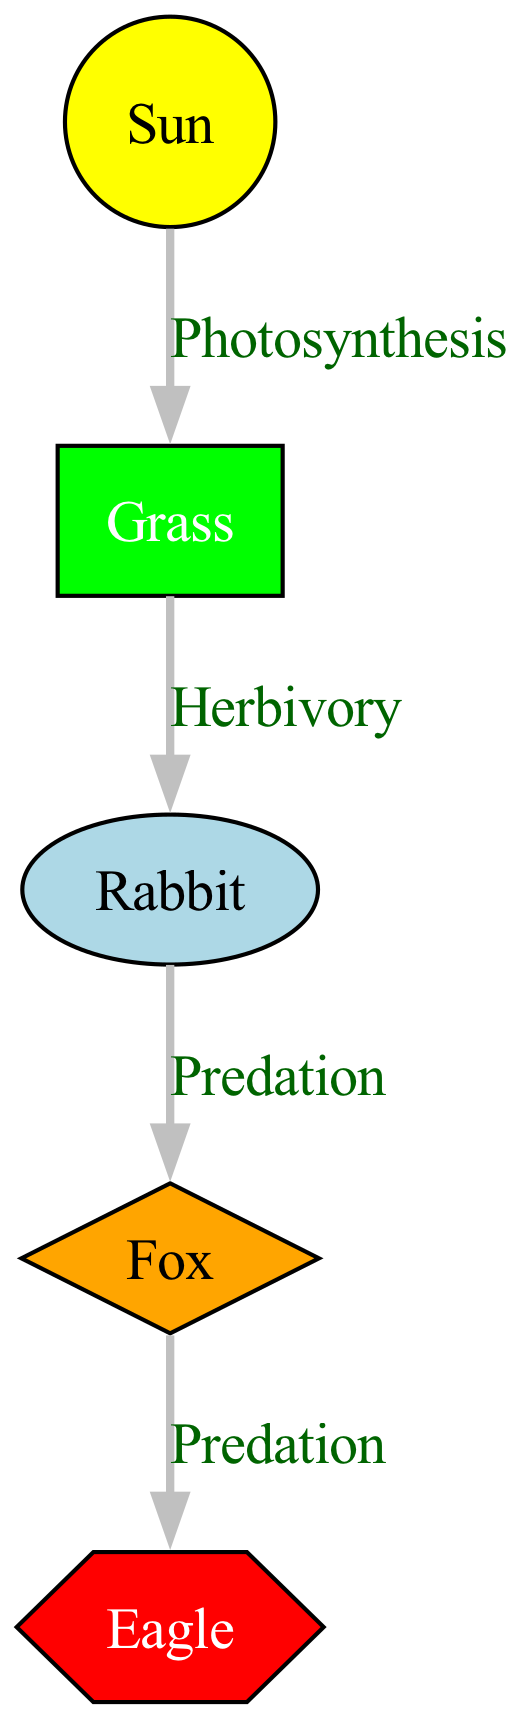What is the primary producer in the food chain? The primary producer is represented by the node labeled "Grass," which is the first organism to convert solar energy into chemical energy through photosynthesis.
Answer: Grass How many nodes are there in total? To find the total number of nodes, we count each unique organism or energy source in the diagram. There are five nodes: Sun, Grass, Rabbit, Fox, and Eagle.
Answer: 5 What type of energy transfer occurs between Grass and Rabbit? The relationship between Grass and Rabbit is illustrated by an edge labeled "Herbivory," which specifies that this is how the Rabbit derives energy from the Grass.
Answer: Herbivory Which trophic level does the Eagle occupy? The Eagle is depicted as a tertiary consumer, which is the third trophic level in the energy transfer hierarchy presented in this food chain.
Answer: Tertiary consumer Which node acts as the energy source for the entire food chain? The node identified as the "Sun" directly feeds energy into the system, which is crucial for all other nodes to exist and perform their respective roles.
Answer: Sun How many energy transfer relationships are represented in the diagram? By counting each edge connecting nodes, we find that there are four distinct relationships outlining how energy is transferred from one organism to another.
Answer: 4 What is the relationship type between Fox and Eagle? The edge that connects Fox to Eagle is labeled "Predation," indicating that the Eagle preys on the Fox, establishing a predator-prey relationship.
Answer: Predation What color represents the primary consumers in the diagram? The primary consumer, represented by the Rabbit in the diagram, is colored light blue, which differentiates its type from the other organisms.
Answer: Light blue What type of node is Grass categorized as? Because Grass synthesizes its energy from sunlight through the process of photosynthesis, it is classified as a primary producer within the ecosystem.
Answer: Primary producer 